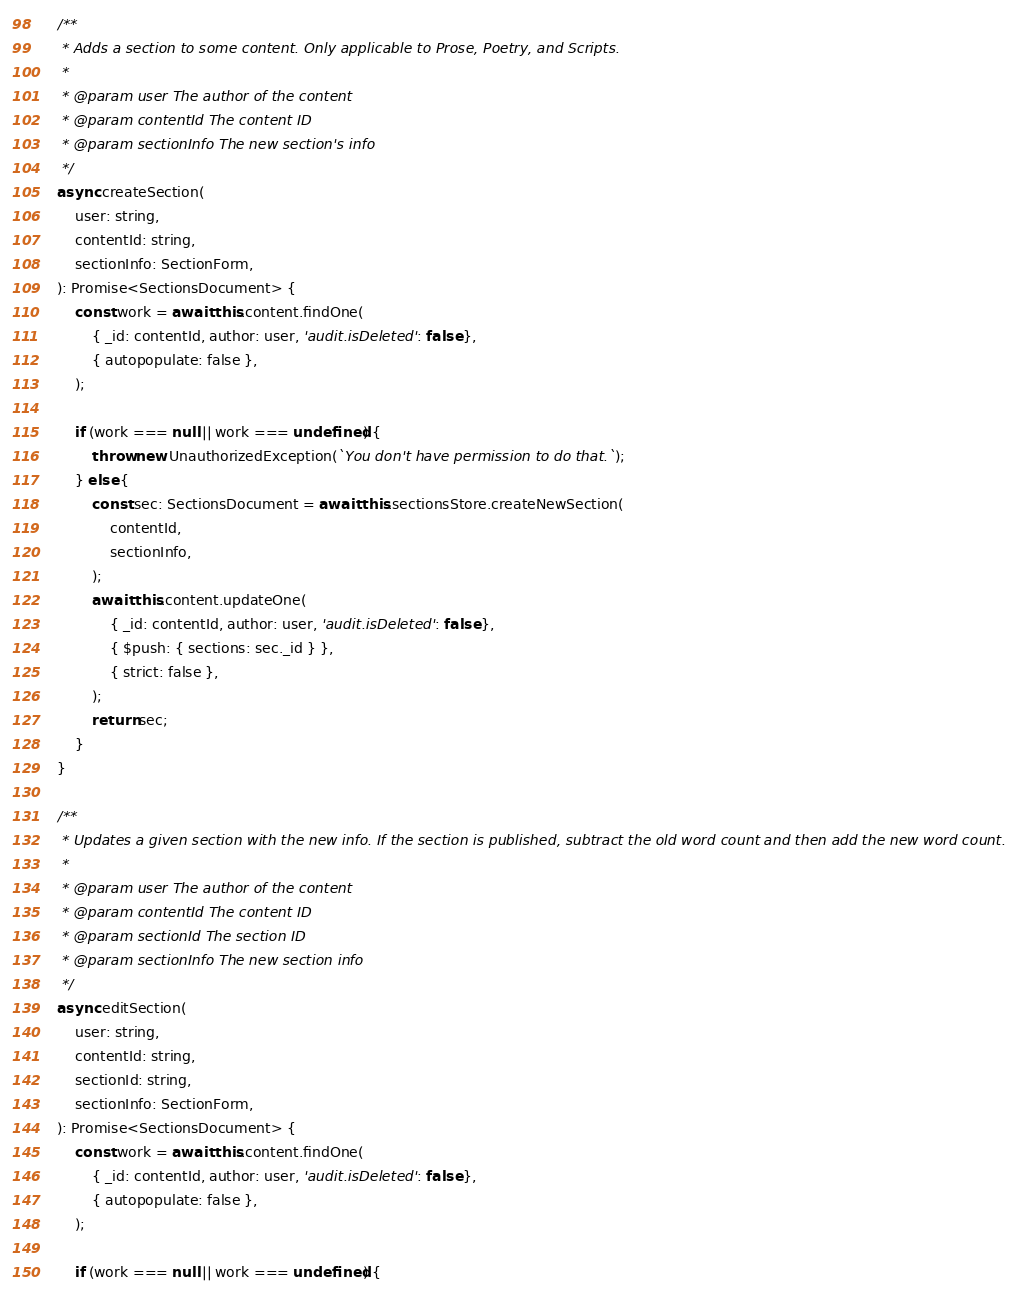Convert code to text. <code><loc_0><loc_0><loc_500><loc_500><_TypeScript_>
    /**
     * Adds a section to some content. Only applicable to Prose, Poetry, and Scripts.
     *
     * @param user The author of the content
     * @param contentId The content ID
     * @param sectionInfo The new section's info
     */
    async createSection(
        user: string,
        contentId: string,
        sectionInfo: SectionForm,
    ): Promise<SectionsDocument> {
        const work = await this.content.findOne(
            { _id: contentId, author: user, 'audit.isDeleted': false },
            { autopopulate: false },
        );

        if (work === null || work === undefined) {
            throw new UnauthorizedException(`You don't have permission to do that.`);
        } else {
            const sec: SectionsDocument = await this.sectionsStore.createNewSection(
                contentId,
                sectionInfo,
            );
            await this.content.updateOne(
                { _id: contentId, author: user, 'audit.isDeleted': false },
                { $push: { sections: sec._id } },
                { strict: false },
            );
            return sec;
        }
    }

    /**
     * Updates a given section with the new info. If the section is published, subtract the old word count and then add the new word count.
     *
     * @param user The author of the content
     * @param contentId The content ID
     * @param sectionId The section ID
     * @param sectionInfo The new section info
     */
    async editSection(
        user: string,
        contentId: string,
        sectionId: string,
        sectionInfo: SectionForm,
    ): Promise<SectionsDocument> {
        const work = await this.content.findOne(
            { _id: contentId, author: user, 'audit.isDeleted': false },
            { autopopulate: false },
        );

        if (work === null || work === undefined) {</code> 